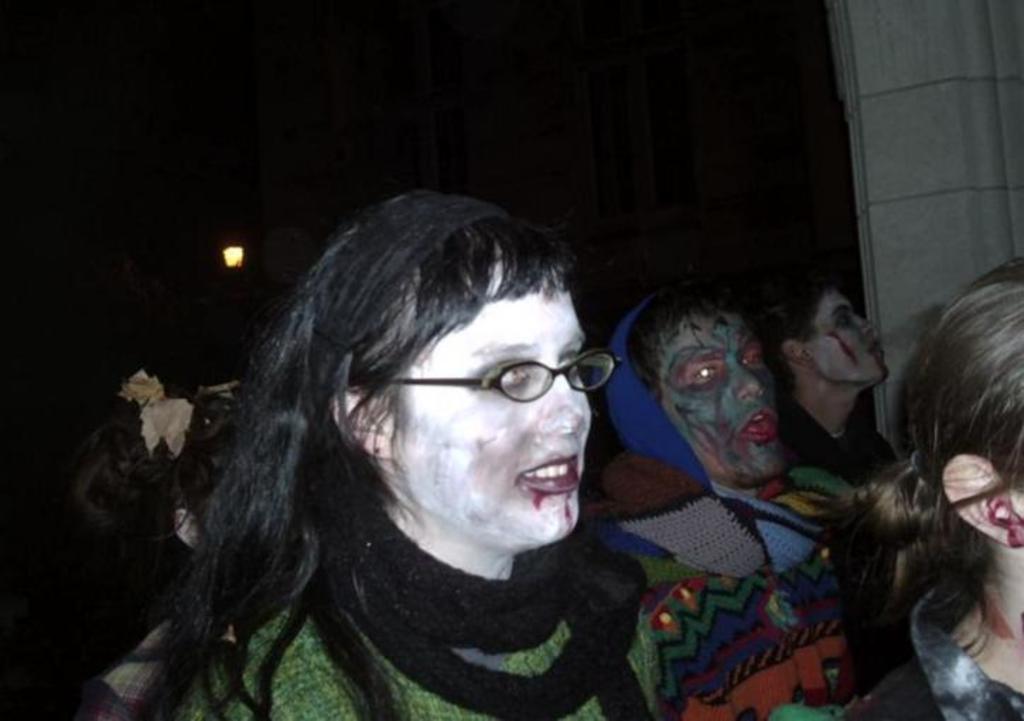How would you summarize this image in a sentence or two? In the center of the image there are people with face paintings. 